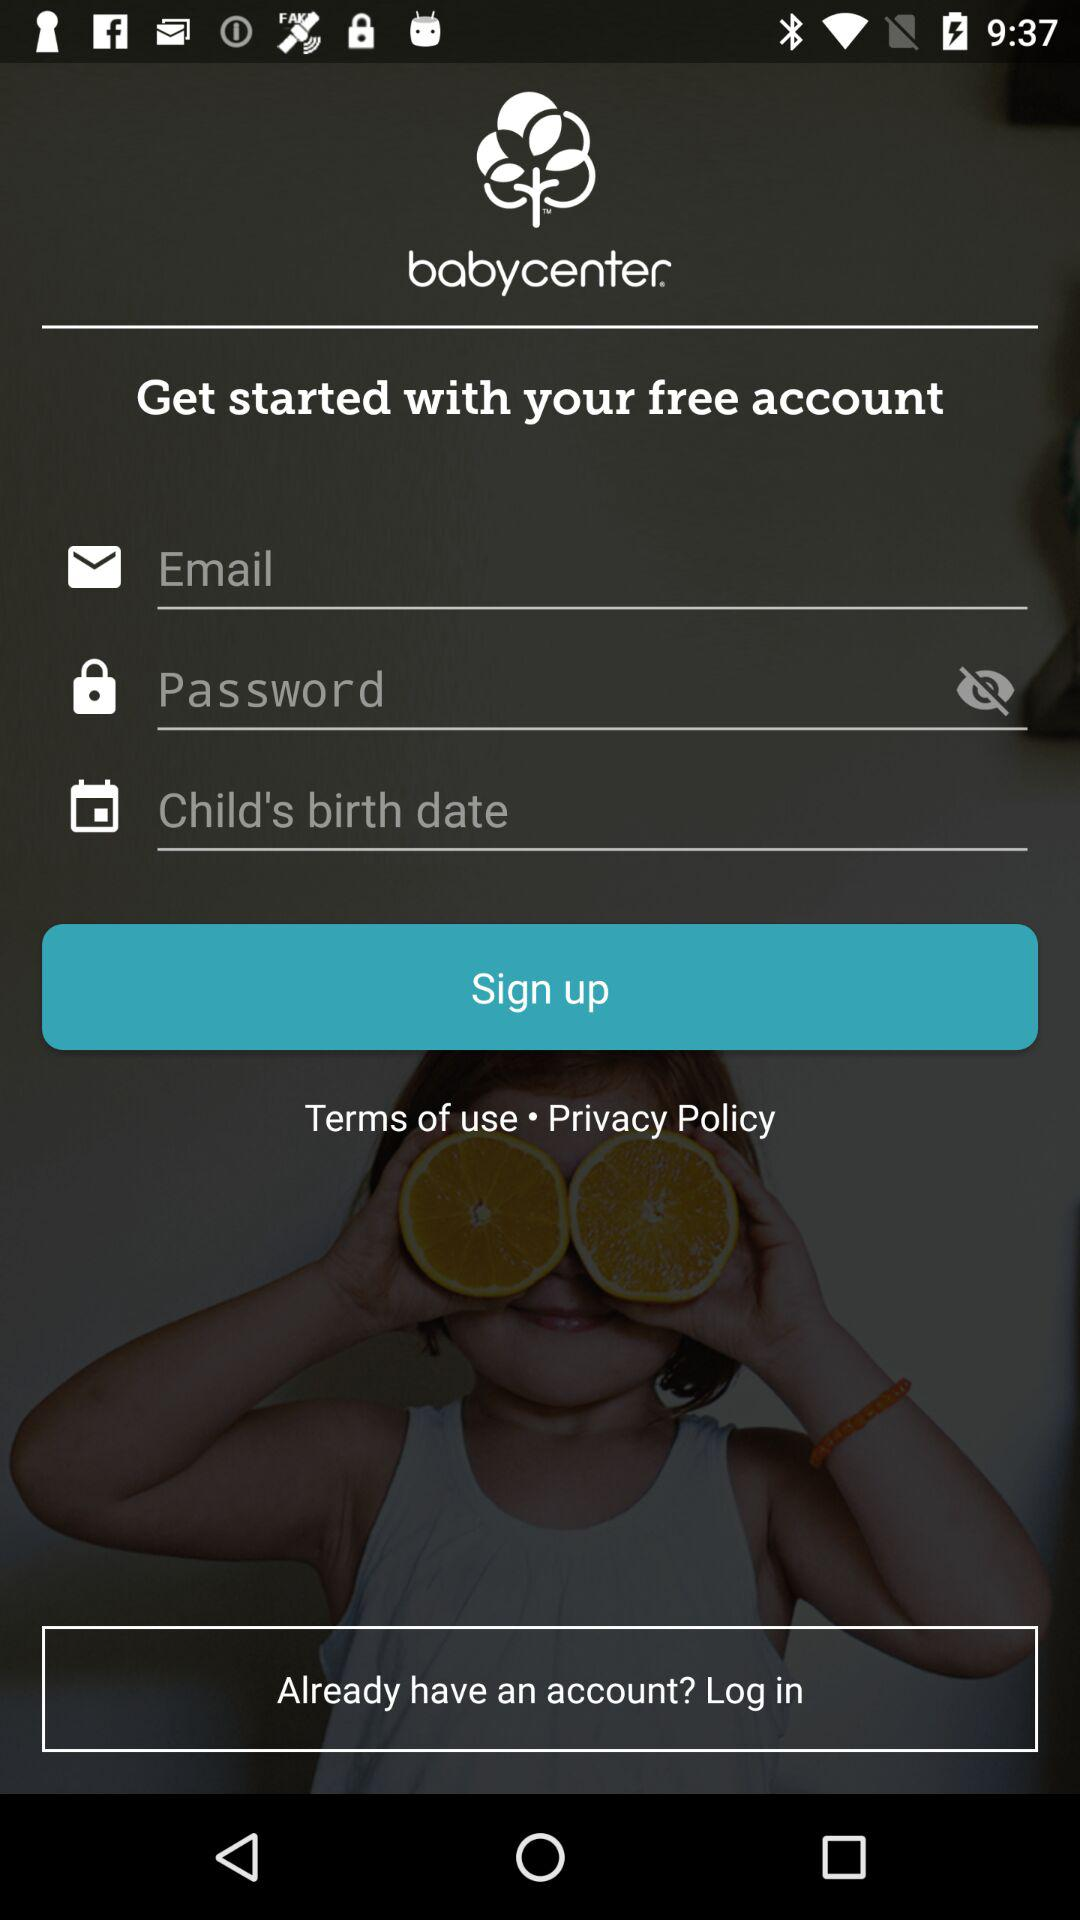What are the requirements to sign up? The requirements to sign up are "Email", "Password" and "Child's birth date". 